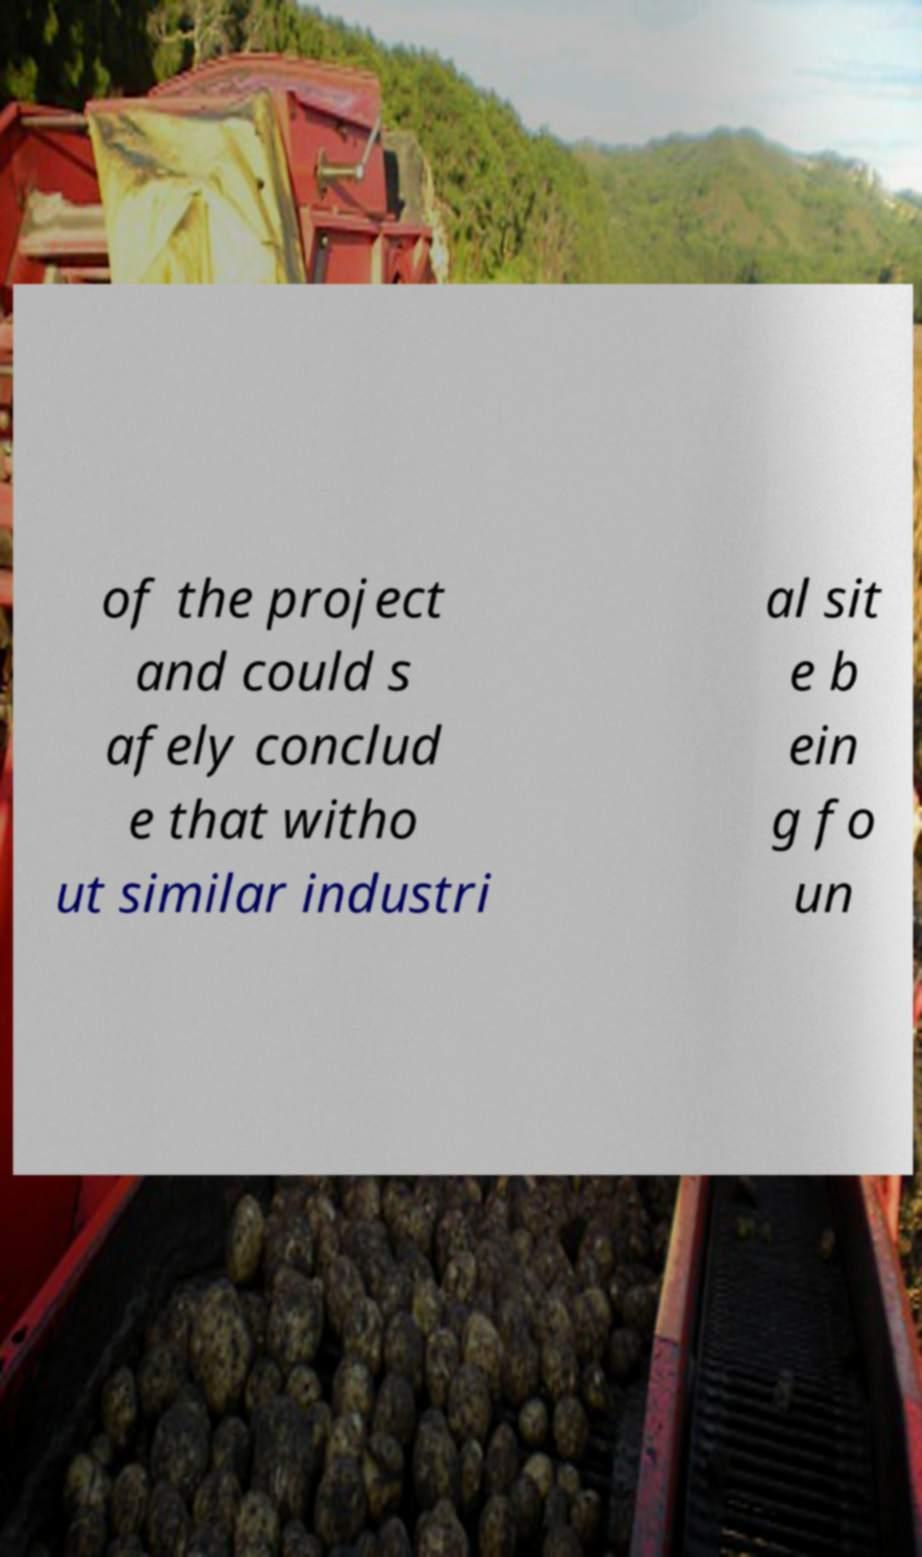Please identify and transcribe the text found in this image. of the project and could s afely conclud e that witho ut similar industri al sit e b ein g fo un 